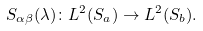<formula> <loc_0><loc_0><loc_500><loc_500>S _ { \alpha \beta } ( \lambda ) \colon L ^ { 2 } ( S _ { a } ) \to L ^ { 2 } ( S _ { b } ) .</formula> 